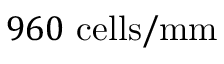<formula> <loc_0><loc_0><loc_500><loc_500>9 6 0 c e l l s / m m</formula> 